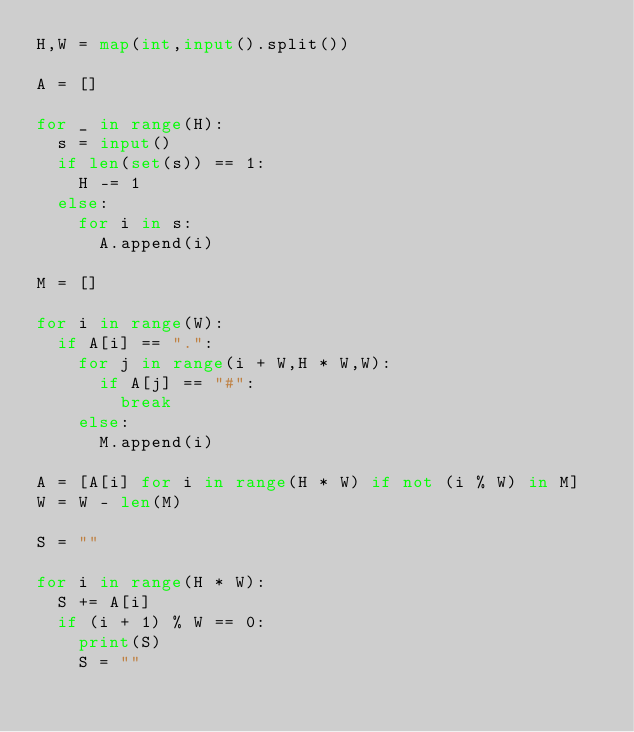Convert code to text. <code><loc_0><loc_0><loc_500><loc_500><_Python_>H,W = map(int,input().split())

A = []

for _ in range(H):
  s = input()
  if len(set(s)) == 1:
    H -= 1
  else:
    for i in s:
      A.append(i)

M = []

for i in range(W):
  if A[i] == ".":
    for j in range(i + W,H * W,W):
      if A[j] == "#":
        break
    else:
      M.append(i)
      
A = [A[i] for i in range(H * W) if not (i % W) in M]
W = W - len(M)

S = ""

for i in range(H * W):
  S += A[i]
  if (i + 1) % W == 0:
    print(S)
    S = ""</code> 